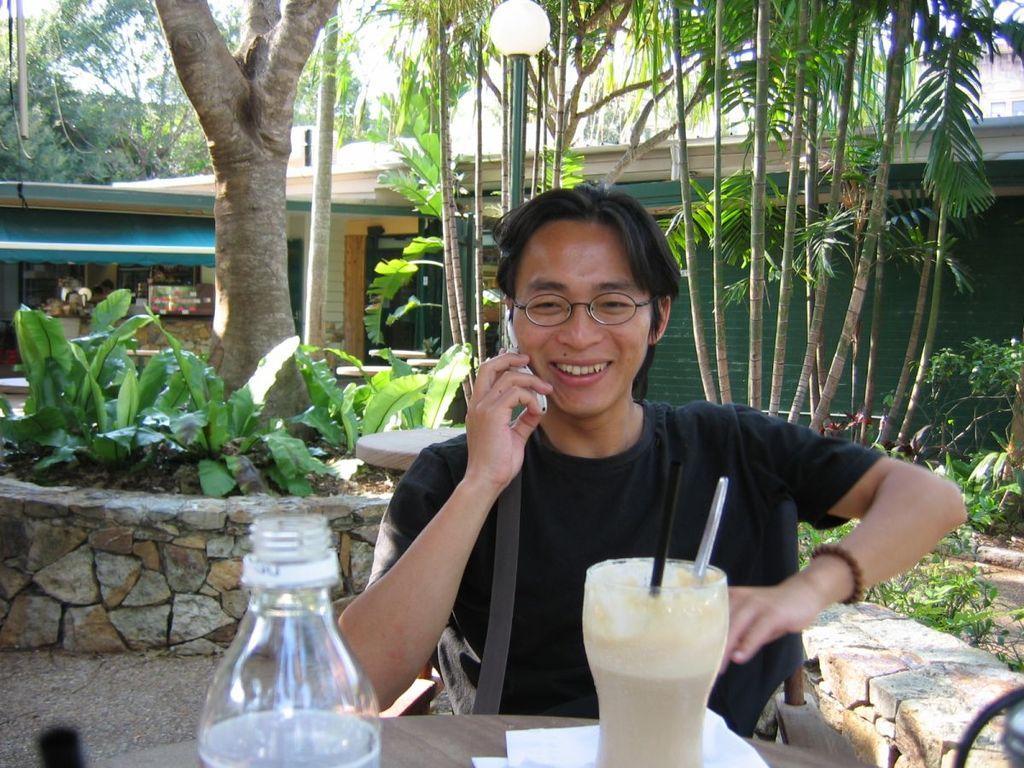Can you describe this image briefly? The person wearing black shirt is speaking in phone and there is milk shake and water bottle in front of him, In background there are trees and a green building. 